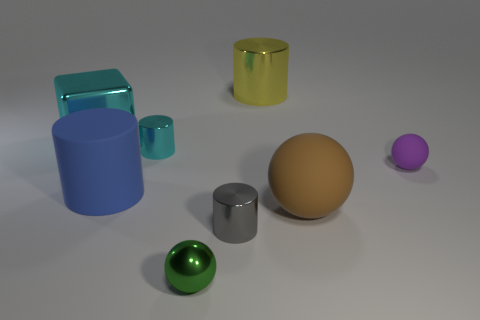Add 1 purple rubber things. How many objects exist? 9 Subtract all balls. How many objects are left? 5 Subtract 0 yellow balls. How many objects are left? 8 Subtract all small objects. Subtract all big brown things. How many objects are left? 3 Add 6 cyan metallic cylinders. How many cyan metallic cylinders are left? 7 Add 7 big blocks. How many big blocks exist? 8 